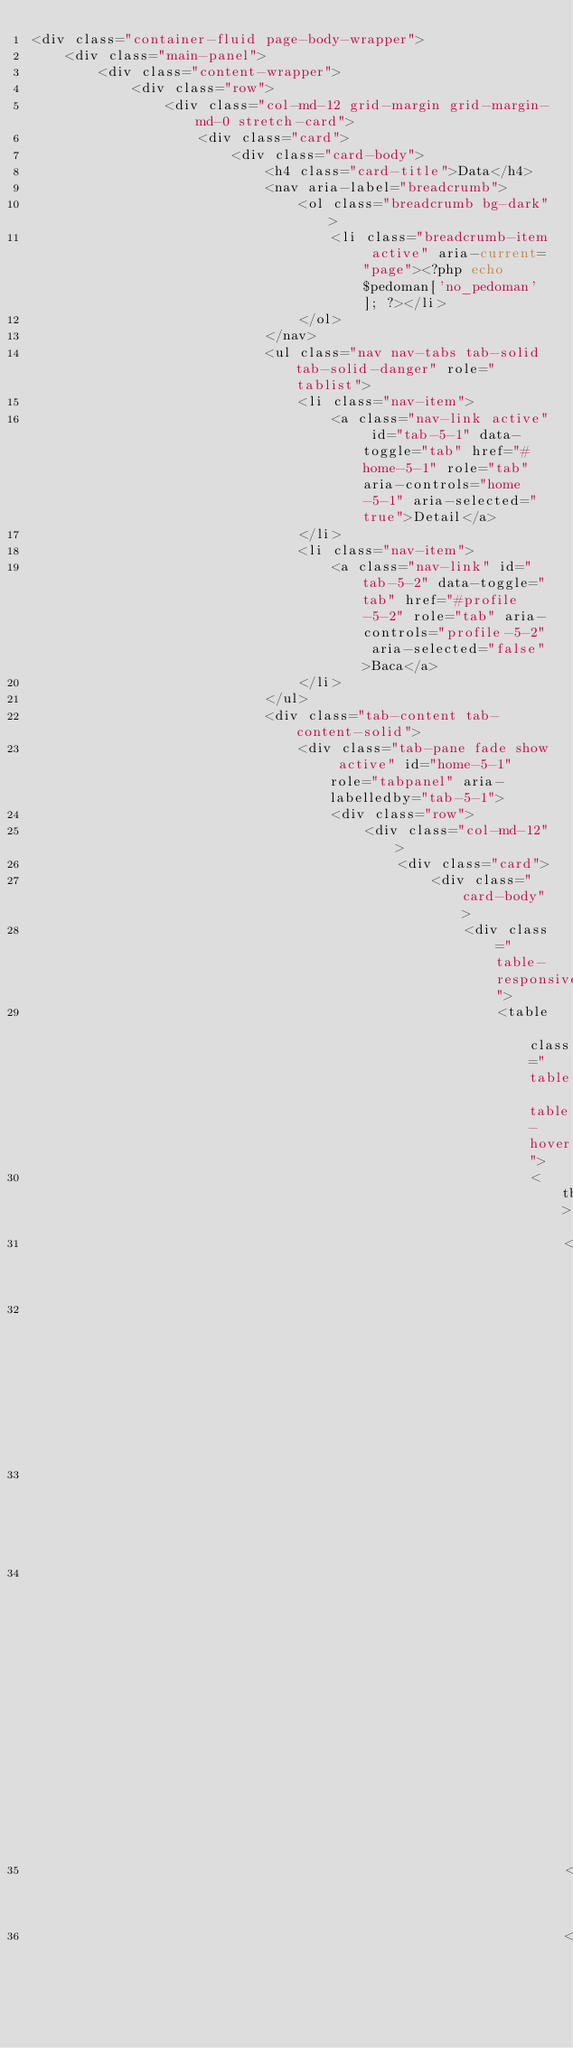Convert code to text. <code><loc_0><loc_0><loc_500><loc_500><_PHP_><div class="container-fluid page-body-wrapper">
    <div class="main-panel">
        <div class="content-wrapper">
            <div class="row">
                <div class="col-md-12 grid-margin grid-margin-md-0 stretch-card">
                    <div class="card">
                        <div class="card-body">
                            <h4 class="card-title">Data</h4>
                            <nav aria-label="breadcrumb">
                                <ol class="breadcrumb bg-dark">
                                    <li class="breadcrumb-item active" aria-current="page"><?php echo $pedoman['no_pedoman']; ?></li>
                                </ol>
                            </nav>
                            <ul class="nav nav-tabs tab-solid tab-solid-danger" role="tablist">
                                <li class="nav-item">
                                    <a class="nav-link active" id="tab-5-1" data-toggle="tab" href="#home-5-1" role="tab" aria-controls="home-5-1" aria-selected="true">Detail</a>
                                </li>
                                <li class="nav-item">
                                    <a class="nav-link" id="tab-5-2" data-toggle="tab" href="#profile-5-2" role="tab" aria-controls="profile-5-2" aria-selected="false">Baca</a>
                                </li>
                            </ul>
                            <div class="tab-content tab-content-solid">
                                <div class="tab-pane fade show active" id="home-5-1" role="tabpanel" aria-labelledby="tab-5-1">
                                    <div class="row">
                                        <div class="col-md-12">
                                            <div class="card">
                                                <div class="card-body">
                                                    <div class="table-responsive">
                                                        <table class="table table-hover">
                                                            <tbody>
                                                                <tr>
                                                                    <th>Id Pedoman</th>
                                                                    <td>:</td>
                                                                    <td><?php echo $pedoman['id_pedoman']; ?></td>
                                                                </tr>
                                                                <tr></code> 